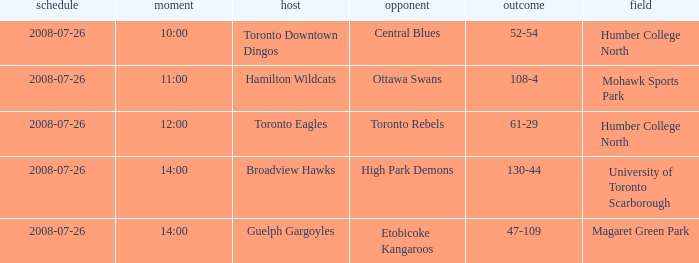With the Ground of Humber College North at 12:00, what was the Away? Toronto Rebels. 